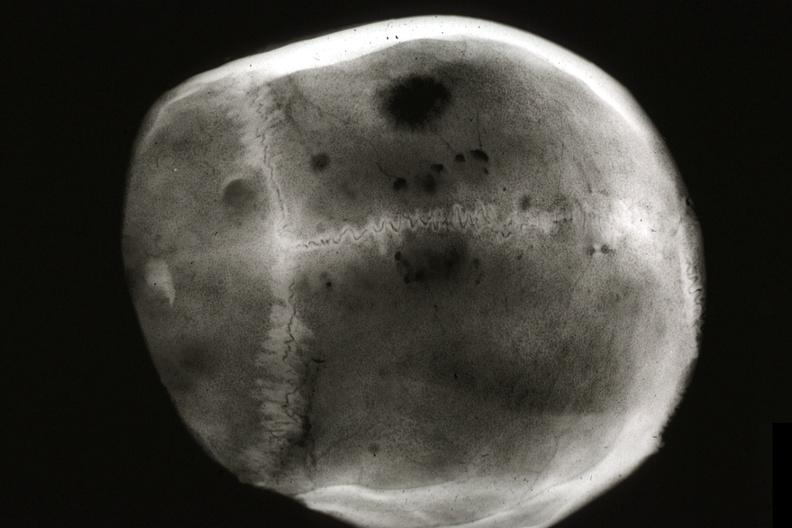what is metastatic carcinoma x-ray?
Answer the question using a single word or phrase. Ray present 